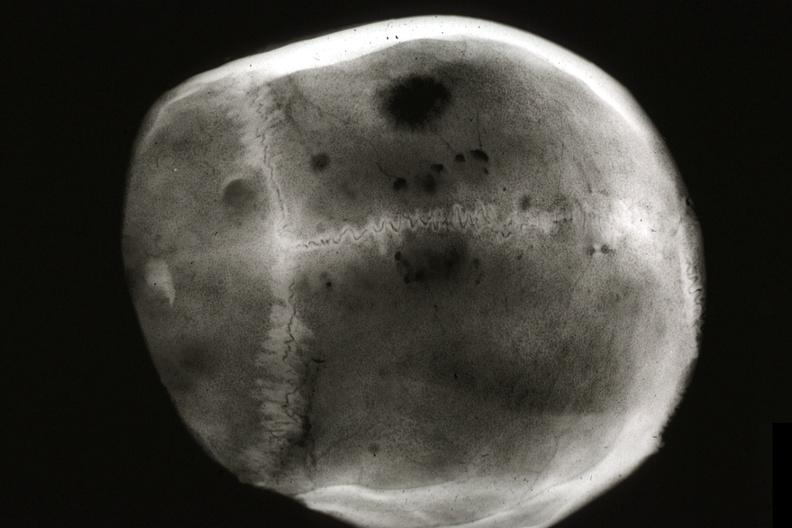what is metastatic carcinoma x-ray?
Answer the question using a single word or phrase. Ray present 